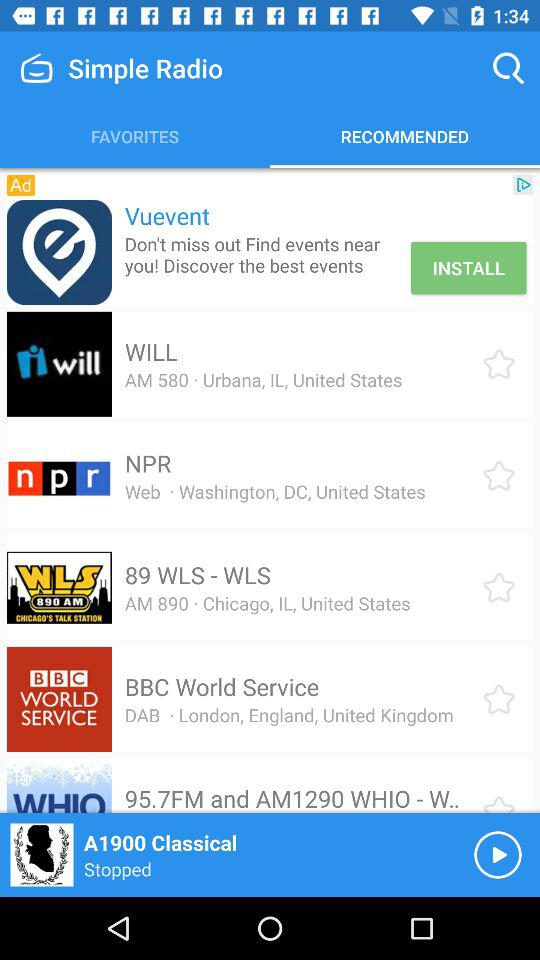Which radio stations are listed in "FAVORITES"?
When the provided information is insufficient, respond with <no answer>. <no answer> 